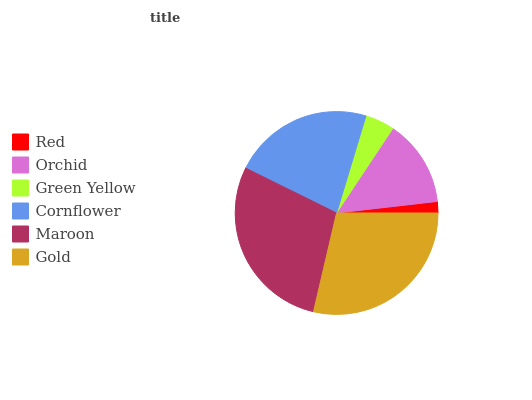Is Red the minimum?
Answer yes or no. Yes. Is Gold the maximum?
Answer yes or no. Yes. Is Orchid the minimum?
Answer yes or no. No. Is Orchid the maximum?
Answer yes or no. No. Is Orchid greater than Red?
Answer yes or no. Yes. Is Red less than Orchid?
Answer yes or no. Yes. Is Red greater than Orchid?
Answer yes or no. No. Is Orchid less than Red?
Answer yes or no. No. Is Cornflower the high median?
Answer yes or no. Yes. Is Orchid the low median?
Answer yes or no. Yes. Is Green Yellow the high median?
Answer yes or no. No. Is Red the low median?
Answer yes or no. No. 